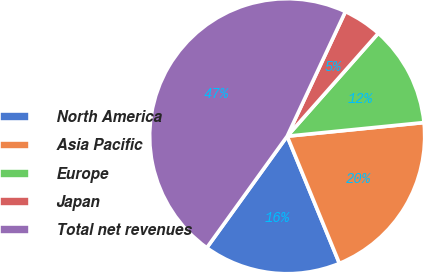Convert chart to OTSL. <chart><loc_0><loc_0><loc_500><loc_500><pie_chart><fcel>North America<fcel>Asia Pacific<fcel>Europe<fcel>Japan<fcel>Total net revenues<nl><fcel>16.14%<fcel>20.38%<fcel>11.89%<fcel>4.57%<fcel>47.02%<nl></chart> 